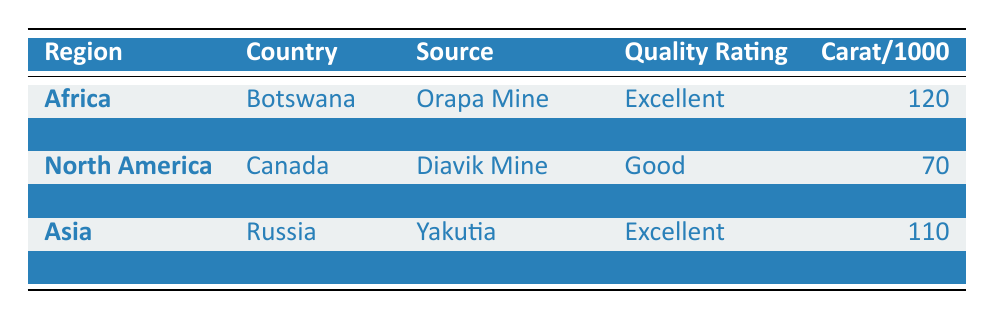What is the highest quality rating among the diamonds listed? The table shows various diamonds with their quality ratings. Scanning through the quality ratings, "Excellent" is the highest quality rating found for diamonds from Botswana (Orapa Mine) and Russia (Yakutia).
Answer: Excellent Which country produces diamonds rated as "Very Good"? The table lists the quality ratings alongside their respective countries, and "Very Good" is specifically associated with South Africa (Cullinan Mine).
Answer: South Africa What is the total carat per 1000 for the diamonds rated "Good"? To find the total carat per 1000 for diamonds rated "Good", we look at both Canada (Diavik Mine) with 70 carats and Australia (Argyle Mine) with 85 carats. Adding them gives us 70 + 85 = 155.
Answer: 155 Is there any diamond source in South America that has a quality rating of "Excellent"? Looking at the table, Brazil is the only diamond source listed in South America, and it has a quality rating of "Fair", not "Excellent". Therefore, the statement is false.
Answer: No How many continents have diamond sources rated "Excellent"? The table shows diamond sources with "Excellent" ratings in two regions: Africa (Botswana) and Asia (Russia). Therefore, two continents are involved.
Answer: 2 Which diamond source has the lowest carat per 1000 and what is its quality rating? Upon reviewing the table, Brazil's Ametista do Sul has the lowest carat per 1000, which is 50, and its quality rating is "Fair".
Answer: Ametista do Sul, Fair What is the average carat per 1000 across all diamond sources listed? To find the average, we need to sum up all carat values: 120 + 90 + 70 + 50 + 110 + 85 = 525. There are 6 sources, so the average is 525 / 6 = 87.5.
Answer: 87.5 Which diamond has a better quality rating: the one from Canada or the one from Brazil? Canada has a diamond rated as "Good" while Brazil's diamond is rated "Fair", so Canada has the better quality rating since "Good" is higher than "Fair".
Answer: Canada Are there more diamond sources in Africa or in Asia? The table shows two diamond sources in Africa (Botswana and South Africa) and one in Asia (Russia). Thus, there are more diamond sources in Africa.
Answer: Africa 